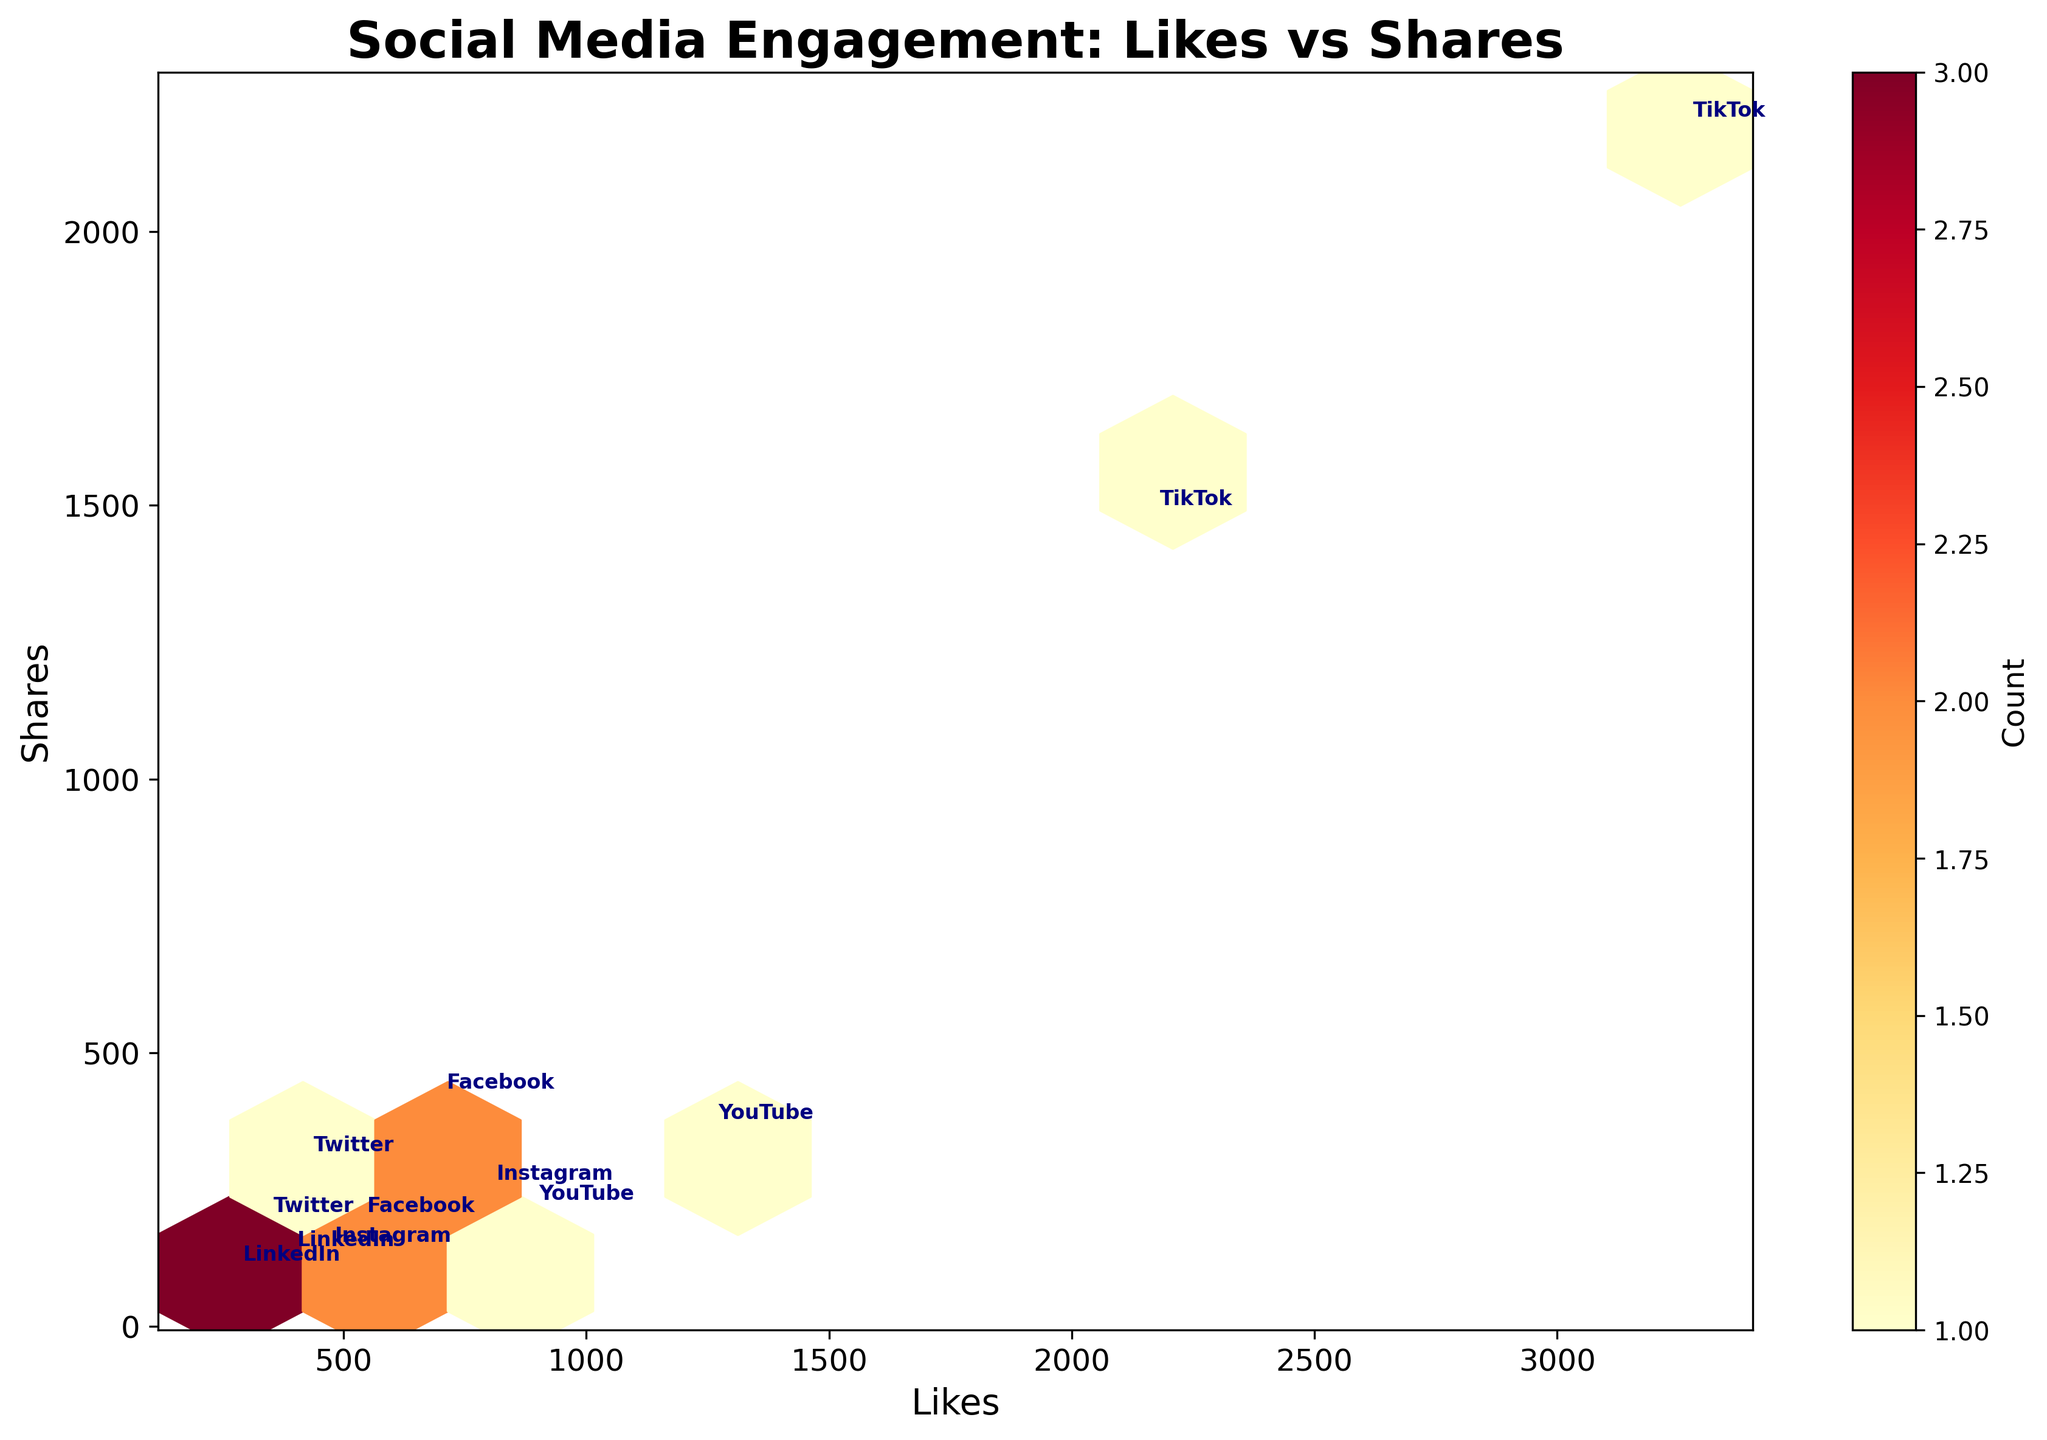What is the title of the figure? The title of the figure is typically found at the top of the plot. In this case, the title reads "Social Media Engagement: Likes vs Shares," explaining that the plot shows likes in relation to shares for various church events across social media platforms.
Answer: Social Media Engagement: Likes vs Shares How many data points are displayed on the plot? Each event represents a data point on the plot. By counting the number of events listed in the data, we see there are 12 events, meaning there are 12 data points visualized.
Answer: 12 Which platform has the highest number of likes and what is the event associated with it? By observing the annotations in the hexbin plot, we identify the position representing the highest number of likes. TikTok is located at the highest like count (3254), associated with the "Worship Music Challenge" event.
Answer: TikTok, Worship Music Challenge What range of likes and shares does the plot cover? The x-axis (likes) and y-axis (shares) range can be inferred from the minimum and maximum values visible in the plot. For likes, it's from approximately 200 to slightly over 3000. For shares, it's from 0 to slightly above 2000.
Answer: Likes: 200 - 3254, Shares: 0 - 2187 Which event on Facebook received the most shares and how many? The annotations locate Facebook-related data points. Among these, the event with the most shares is the "Charity Fundraiser," which received 412 shares.
Answer: Charity Fundraiser, 412 shares Compare the total engagement (sum of likes and shares) for TikTok events. Which TikTok event had higher total engagement? We sum the likes and shares for the TikTok events: "Volunteer Day Highlights" has 2156 likes and 1478 shares (total 3634), while "Worship Music Challenge" has 3254 likes and 2187 shares (total 5441). The event with higher engagement is "Worship Music Challenge."
Answer: Worship Music Challenge Is there any platform that appears multiple times in the highest density area of the hexbin plot? The highest density area in a hexbin plot is marked by darker shading. Observing annotations in these areas, we can identify any repeated platforms. Instagram appears multiple times, indicating that it has more consistent engagement rates in medium-density areas.
Answer: Instagram Which platform seems to have the widest variation in its engagement metrics (likes and shares)? By comparing the spread of data points annotated by platform, TikTok shows a wider range of both likes and shares, indicating substantial variation in engagement.
Answer: TikTok Assess the general relationship between likes and shares across all platforms; does one typically increase with the other? The hexagonal binning in the plot generally slopes upwards from the bottom-left to the top-right. This suggests a positive correlation, meaning as likes increase, shares tend to increase as well.
Answer: Yes, likes generally increase with shares 